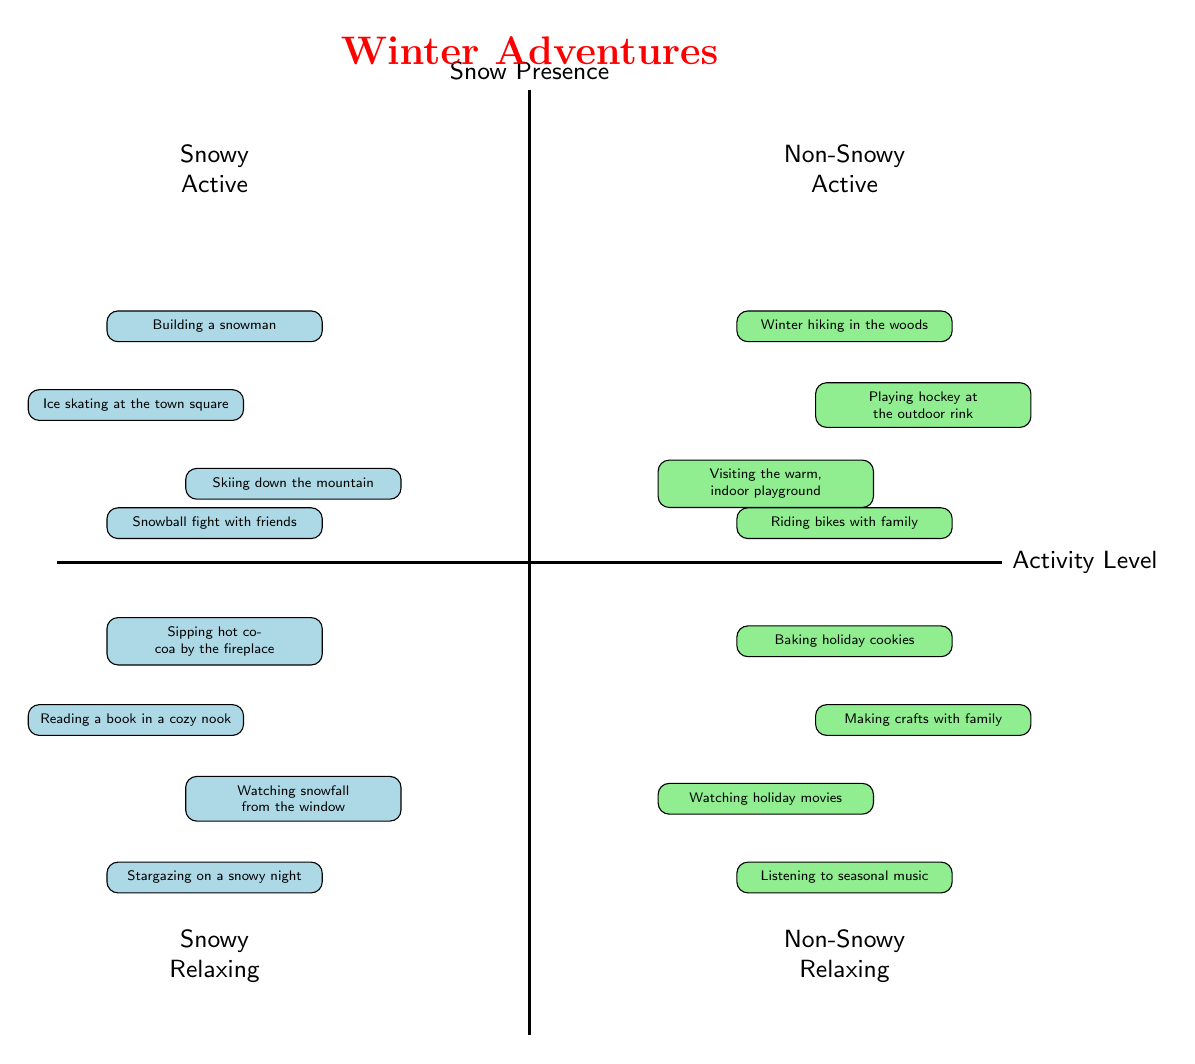What activities are listed under Snowy Active? The Snowy Active quadrant includes activities that are physically engaging and take place in snowy conditions. The activities listed are: building a snowman, ice skating at the town square, skiing down the mountain, and having a snowball fight with friends
Answer: Building a snowman, ice skating at the town square, skiing down the mountain, snowball fight with friends How many activities are there in the Non-Snowy Relaxing quadrant? The Non-Snowy Relaxing quadrant consists of relaxing activities that occur in non-snowy conditions. There are four activities listed: baking holiday cookies, making crafts with family, watching holiday movies, and listening to seasonal music. Therefore, the total is four
Answer: 4 Which quadrant has activities that are both Active and Non-Snowy? The quadrant that represents activities that are Active and Non-Snowy is the Non-Snowy Active quadrant. The activities include winter hiking in the woods, playing hockey at the outdoor rink, visiting the warm indoor playground, and riding bikes with family
Answer: Non-Snowy Active What are the two major categories of activities in the diagram? The diagram categorizes the winter activities into two major levels based on activity type: Active and Relaxing. These categories are represented in the two vertical divisions of the chart
Answer: Active and Relaxing Which activity is likely to be done on a snowy night according to the diagram? The Snowy Relaxing quadrant includes activities suited for snowy nights. One of these activities is stargazing on a snowy night, which suggests it can be enjoyed while it is snowy. Thus, stargazing on a snowy night fits the criteria
Answer: Stargazing on a snowy night How many activities involve snowball fights? Looking at the diagram, the only activity related to snowball fights is specifically stated under the Snowy Active quadrant. It mentions "snowball fight with friends" as one of the four activities listed in that quadrant
Answer: 1 What is the unique feature of the Non-Snowy Active quadrant? The Non-Snowy Active quadrant encompasses activities that are active and do not involve snow. This quadrant features activities such as winter hiking in the woods and playing hockey at the outdoor rink, showcasing a range of fun yard-specific activities in a non-snowy environment
Answer: Active activities without snow How many categories are there for snow presence in the diagram? The diagram organizes the activities based on the presence of snow. There are two clear categories: Snowy and Non-Snowy, which provide a distinction between the activities depending on the snow conditions. Therefore, the total categories for snow presence are two
Answer: 2 